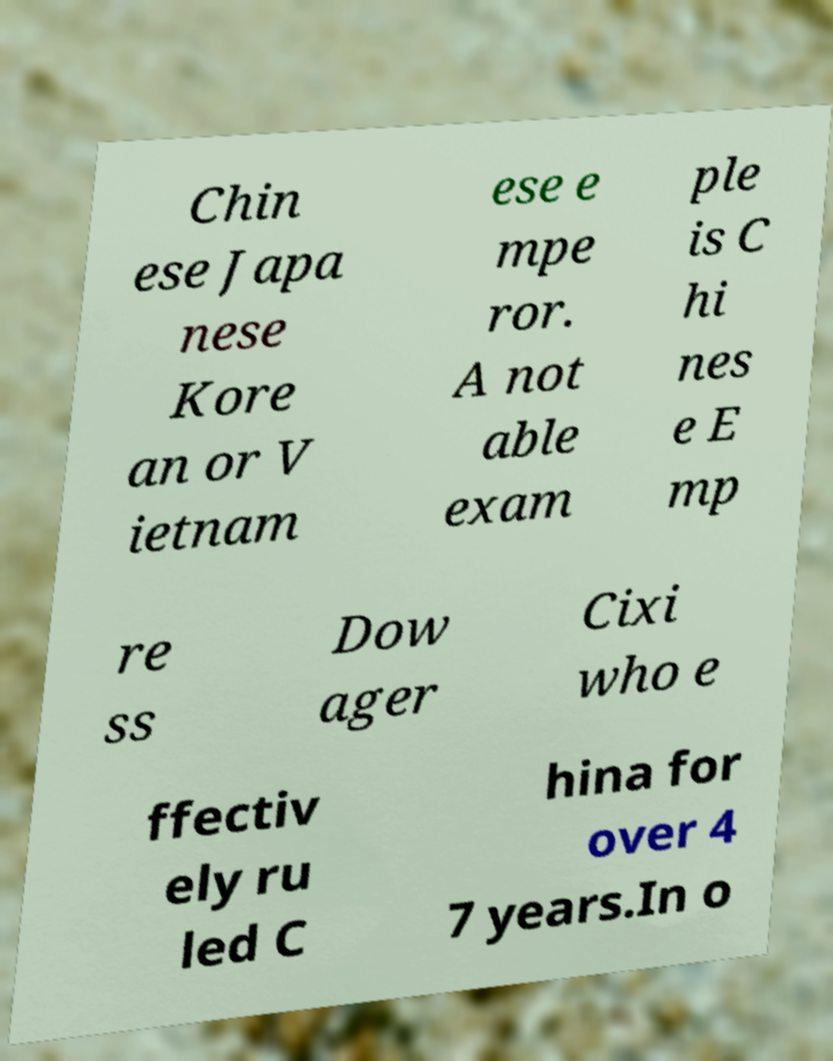Please identify and transcribe the text found in this image. Chin ese Japa nese Kore an or V ietnam ese e mpe ror. A not able exam ple is C hi nes e E mp re ss Dow ager Cixi who e ffectiv ely ru led C hina for over 4 7 years.In o 